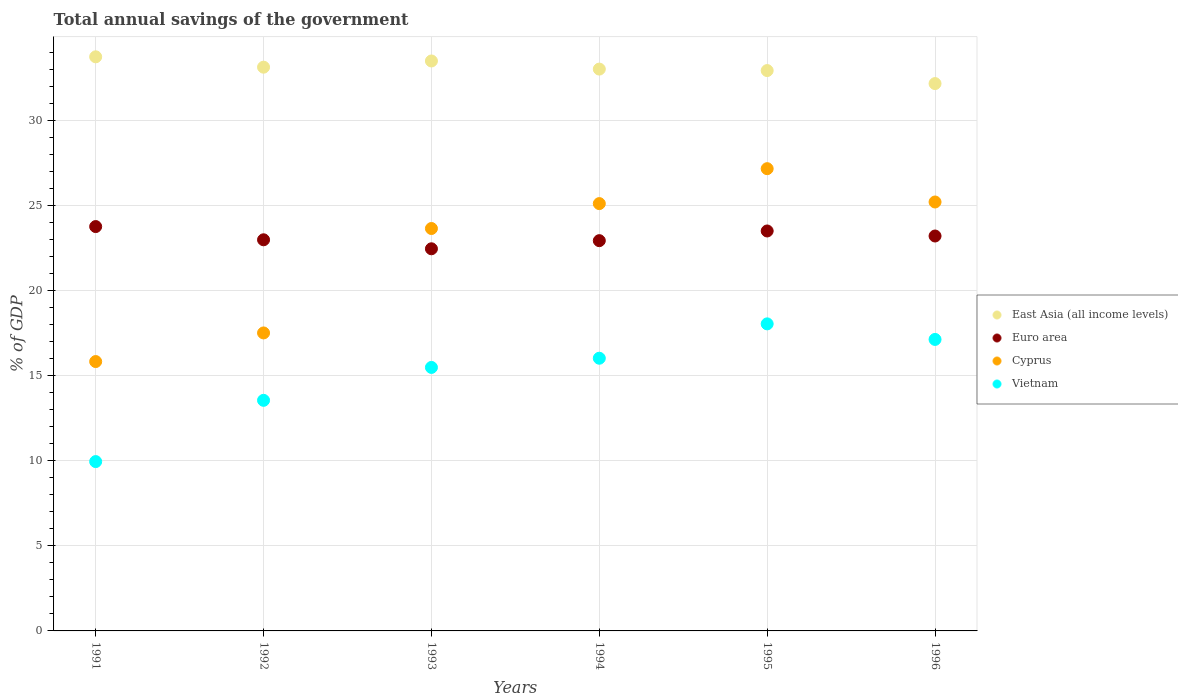Is the number of dotlines equal to the number of legend labels?
Your answer should be compact. Yes. What is the total annual savings of the government in Cyprus in 1995?
Ensure brevity in your answer.  27.17. Across all years, what is the maximum total annual savings of the government in Vietnam?
Keep it short and to the point. 18.05. Across all years, what is the minimum total annual savings of the government in Vietnam?
Keep it short and to the point. 9.95. In which year was the total annual savings of the government in East Asia (all income levels) minimum?
Your response must be concise. 1996. What is the total total annual savings of the government in Euro area in the graph?
Keep it short and to the point. 138.88. What is the difference between the total annual savings of the government in East Asia (all income levels) in 1991 and that in 1994?
Your response must be concise. 0.72. What is the difference between the total annual savings of the government in East Asia (all income levels) in 1994 and the total annual savings of the government in Cyprus in 1996?
Make the answer very short. 7.81. What is the average total annual savings of the government in Vietnam per year?
Ensure brevity in your answer.  15.03. In the year 1994, what is the difference between the total annual savings of the government in Euro area and total annual savings of the government in Cyprus?
Ensure brevity in your answer.  -2.18. What is the ratio of the total annual savings of the government in East Asia (all income levels) in 1992 to that in 1993?
Provide a short and direct response. 0.99. Is the total annual savings of the government in East Asia (all income levels) in 1991 less than that in 1993?
Ensure brevity in your answer.  No. What is the difference between the highest and the second highest total annual savings of the government in Cyprus?
Keep it short and to the point. 1.96. What is the difference between the highest and the lowest total annual savings of the government in Vietnam?
Keep it short and to the point. 8.1. In how many years, is the total annual savings of the government in Euro area greater than the average total annual savings of the government in Euro area taken over all years?
Offer a very short reply. 3. Is it the case that in every year, the sum of the total annual savings of the government in Euro area and total annual savings of the government in East Asia (all income levels)  is greater than the sum of total annual savings of the government in Vietnam and total annual savings of the government in Cyprus?
Offer a very short reply. Yes. Does the total annual savings of the government in Euro area monotonically increase over the years?
Your answer should be very brief. No. Is the total annual savings of the government in Cyprus strictly less than the total annual savings of the government in Euro area over the years?
Offer a very short reply. No. How many dotlines are there?
Your answer should be compact. 4. How many years are there in the graph?
Provide a succinct answer. 6. What is the difference between two consecutive major ticks on the Y-axis?
Keep it short and to the point. 5. Does the graph contain any zero values?
Your response must be concise. No. How are the legend labels stacked?
Your answer should be very brief. Vertical. What is the title of the graph?
Provide a short and direct response. Total annual savings of the government. Does "OECD members" appear as one of the legend labels in the graph?
Keep it short and to the point. No. What is the label or title of the X-axis?
Provide a succinct answer. Years. What is the label or title of the Y-axis?
Your response must be concise. % of GDP. What is the % of GDP in East Asia (all income levels) in 1991?
Keep it short and to the point. 33.75. What is the % of GDP in Euro area in 1991?
Your answer should be compact. 23.77. What is the % of GDP of Cyprus in 1991?
Keep it short and to the point. 15.83. What is the % of GDP in Vietnam in 1991?
Offer a very short reply. 9.95. What is the % of GDP of East Asia (all income levels) in 1992?
Give a very brief answer. 33.14. What is the % of GDP of Euro area in 1992?
Provide a short and direct response. 22.99. What is the % of GDP in Cyprus in 1992?
Your answer should be very brief. 17.52. What is the % of GDP in Vietnam in 1992?
Provide a short and direct response. 13.55. What is the % of GDP in East Asia (all income levels) in 1993?
Offer a very short reply. 33.5. What is the % of GDP in Euro area in 1993?
Your response must be concise. 22.46. What is the % of GDP in Cyprus in 1993?
Offer a terse response. 23.65. What is the % of GDP in Vietnam in 1993?
Provide a succinct answer. 15.49. What is the % of GDP of East Asia (all income levels) in 1994?
Your answer should be very brief. 33.02. What is the % of GDP of Euro area in 1994?
Offer a very short reply. 22.94. What is the % of GDP in Cyprus in 1994?
Your response must be concise. 25.12. What is the % of GDP of Vietnam in 1994?
Provide a short and direct response. 16.03. What is the % of GDP in East Asia (all income levels) in 1995?
Keep it short and to the point. 32.94. What is the % of GDP in Euro area in 1995?
Keep it short and to the point. 23.51. What is the % of GDP in Cyprus in 1995?
Provide a succinct answer. 27.17. What is the % of GDP of Vietnam in 1995?
Your answer should be very brief. 18.05. What is the % of GDP of East Asia (all income levels) in 1996?
Provide a succinct answer. 32.17. What is the % of GDP in Euro area in 1996?
Your answer should be very brief. 23.21. What is the % of GDP in Cyprus in 1996?
Make the answer very short. 25.21. What is the % of GDP in Vietnam in 1996?
Offer a very short reply. 17.13. Across all years, what is the maximum % of GDP of East Asia (all income levels)?
Provide a succinct answer. 33.75. Across all years, what is the maximum % of GDP in Euro area?
Make the answer very short. 23.77. Across all years, what is the maximum % of GDP of Cyprus?
Provide a short and direct response. 27.17. Across all years, what is the maximum % of GDP of Vietnam?
Offer a terse response. 18.05. Across all years, what is the minimum % of GDP of East Asia (all income levels)?
Your answer should be compact. 32.17. Across all years, what is the minimum % of GDP of Euro area?
Keep it short and to the point. 22.46. Across all years, what is the minimum % of GDP in Cyprus?
Offer a very short reply. 15.83. Across all years, what is the minimum % of GDP in Vietnam?
Give a very brief answer. 9.95. What is the total % of GDP in East Asia (all income levels) in the graph?
Ensure brevity in your answer.  198.52. What is the total % of GDP in Euro area in the graph?
Keep it short and to the point. 138.88. What is the total % of GDP of Cyprus in the graph?
Your answer should be very brief. 134.51. What is the total % of GDP in Vietnam in the graph?
Provide a short and direct response. 90.21. What is the difference between the % of GDP of East Asia (all income levels) in 1991 and that in 1992?
Your answer should be compact. 0.61. What is the difference between the % of GDP in Euro area in 1991 and that in 1992?
Make the answer very short. 0.78. What is the difference between the % of GDP in Cyprus in 1991 and that in 1992?
Ensure brevity in your answer.  -1.68. What is the difference between the % of GDP in Vietnam in 1991 and that in 1992?
Provide a short and direct response. -3.6. What is the difference between the % of GDP of East Asia (all income levels) in 1991 and that in 1993?
Offer a terse response. 0.24. What is the difference between the % of GDP of Euro area in 1991 and that in 1993?
Your response must be concise. 1.31. What is the difference between the % of GDP of Cyprus in 1991 and that in 1993?
Offer a very short reply. -7.82. What is the difference between the % of GDP of Vietnam in 1991 and that in 1993?
Your response must be concise. -5.54. What is the difference between the % of GDP in East Asia (all income levels) in 1991 and that in 1994?
Keep it short and to the point. 0.72. What is the difference between the % of GDP of Euro area in 1991 and that in 1994?
Offer a very short reply. 0.83. What is the difference between the % of GDP of Cyprus in 1991 and that in 1994?
Provide a short and direct response. -9.28. What is the difference between the % of GDP in Vietnam in 1991 and that in 1994?
Your response must be concise. -6.08. What is the difference between the % of GDP in East Asia (all income levels) in 1991 and that in 1995?
Make the answer very short. 0.81. What is the difference between the % of GDP of Euro area in 1991 and that in 1995?
Ensure brevity in your answer.  0.26. What is the difference between the % of GDP of Cyprus in 1991 and that in 1995?
Provide a succinct answer. -11.34. What is the difference between the % of GDP of Vietnam in 1991 and that in 1995?
Give a very brief answer. -8.1. What is the difference between the % of GDP of East Asia (all income levels) in 1991 and that in 1996?
Offer a terse response. 1.57. What is the difference between the % of GDP in Euro area in 1991 and that in 1996?
Provide a succinct answer. 0.55. What is the difference between the % of GDP in Cyprus in 1991 and that in 1996?
Ensure brevity in your answer.  -9.38. What is the difference between the % of GDP in Vietnam in 1991 and that in 1996?
Provide a short and direct response. -7.18. What is the difference between the % of GDP of East Asia (all income levels) in 1992 and that in 1993?
Your response must be concise. -0.36. What is the difference between the % of GDP of Euro area in 1992 and that in 1993?
Your answer should be compact. 0.53. What is the difference between the % of GDP in Cyprus in 1992 and that in 1993?
Your response must be concise. -6.14. What is the difference between the % of GDP in Vietnam in 1992 and that in 1993?
Offer a terse response. -1.93. What is the difference between the % of GDP in East Asia (all income levels) in 1992 and that in 1994?
Your answer should be compact. 0.11. What is the difference between the % of GDP in Euro area in 1992 and that in 1994?
Your answer should be very brief. 0.05. What is the difference between the % of GDP of Cyprus in 1992 and that in 1994?
Keep it short and to the point. -7.6. What is the difference between the % of GDP in Vietnam in 1992 and that in 1994?
Provide a succinct answer. -2.47. What is the difference between the % of GDP of East Asia (all income levels) in 1992 and that in 1995?
Your answer should be compact. 0.2. What is the difference between the % of GDP in Euro area in 1992 and that in 1995?
Give a very brief answer. -0.52. What is the difference between the % of GDP in Cyprus in 1992 and that in 1995?
Provide a succinct answer. -9.66. What is the difference between the % of GDP in Vietnam in 1992 and that in 1995?
Ensure brevity in your answer.  -4.49. What is the difference between the % of GDP of East Asia (all income levels) in 1992 and that in 1996?
Your answer should be very brief. 0.96. What is the difference between the % of GDP in Euro area in 1992 and that in 1996?
Offer a very short reply. -0.22. What is the difference between the % of GDP in Cyprus in 1992 and that in 1996?
Give a very brief answer. -7.7. What is the difference between the % of GDP in Vietnam in 1992 and that in 1996?
Ensure brevity in your answer.  -3.58. What is the difference between the % of GDP in East Asia (all income levels) in 1993 and that in 1994?
Your answer should be compact. 0.48. What is the difference between the % of GDP in Euro area in 1993 and that in 1994?
Offer a terse response. -0.48. What is the difference between the % of GDP in Cyprus in 1993 and that in 1994?
Your answer should be very brief. -1.46. What is the difference between the % of GDP in Vietnam in 1993 and that in 1994?
Give a very brief answer. -0.54. What is the difference between the % of GDP in East Asia (all income levels) in 1993 and that in 1995?
Ensure brevity in your answer.  0.56. What is the difference between the % of GDP of Euro area in 1993 and that in 1995?
Your answer should be very brief. -1.05. What is the difference between the % of GDP in Cyprus in 1993 and that in 1995?
Ensure brevity in your answer.  -3.52. What is the difference between the % of GDP in Vietnam in 1993 and that in 1995?
Provide a short and direct response. -2.56. What is the difference between the % of GDP in East Asia (all income levels) in 1993 and that in 1996?
Provide a short and direct response. 1.33. What is the difference between the % of GDP of Euro area in 1993 and that in 1996?
Provide a succinct answer. -0.75. What is the difference between the % of GDP in Cyprus in 1993 and that in 1996?
Give a very brief answer. -1.56. What is the difference between the % of GDP in Vietnam in 1993 and that in 1996?
Keep it short and to the point. -1.65. What is the difference between the % of GDP in East Asia (all income levels) in 1994 and that in 1995?
Offer a very short reply. 0.09. What is the difference between the % of GDP in Euro area in 1994 and that in 1995?
Keep it short and to the point. -0.57. What is the difference between the % of GDP of Cyprus in 1994 and that in 1995?
Give a very brief answer. -2.05. What is the difference between the % of GDP of Vietnam in 1994 and that in 1995?
Give a very brief answer. -2.02. What is the difference between the % of GDP of East Asia (all income levels) in 1994 and that in 1996?
Ensure brevity in your answer.  0.85. What is the difference between the % of GDP in Euro area in 1994 and that in 1996?
Offer a terse response. -0.27. What is the difference between the % of GDP of Cyprus in 1994 and that in 1996?
Your answer should be very brief. -0.09. What is the difference between the % of GDP in Vietnam in 1994 and that in 1996?
Ensure brevity in your answer.  -1.11. What is the difference between the % of GDP in East Asia (all income levels) in 1995 and that in 1996?
Give a very brief answer. 0.76. What is the difference between the % of GDP in Euro area in 1995 and that in 1996?
Keep it short and to the point. 0.3. What is the difference between the % of GDP of Cyprus in 1995 and that in 1996?
Your answer should be compact. 1.96. What is the difference between the % of GDP in Vietnam in 1995 and that in 1996?
Give a very brief answer. 0.91. What is the difference between the % of GDP in East Asia (all income levels) in 1991 and the % of GDP in Euro area in 1992?
Make the answer very short. 10.76. What is the difference between the % of GDP of East Asia (all income levels) in 1991 and the % of GDP of Cyprus in 1992?
Offer a terse response. 16.23. What is the difference between the % of GDP in East Asia (all income levels) in 1991 and the % of GDP in Vietnam in 1992?
Ensure brevity in your answer.  20.19. What is the difference between the % of GDP in Euro area in 1991 and the % of GDP in Cyprus in 1992?
Offer a very short reply. 6.25. What is the difference between the % of GDP of Euro area in 1991 and the % of GDP of Vietnam in 1992?
Ensure brevity in your answer.  10.21. What is the difference between the % of GDP in Cyprus in 1991 and the % of GDP in Vietnam in 1992?
Give a very brief answer. 2.28. What is the difference between the % of GDP of East Asia (all income levels) in 1991 and the % of GDP of Euro area in 1993?
Your response must be concise. 11.28. What is the difference between the % of GDP of East Asia (all income levels) in 1991 and the % of GDP of Cyprus in 1993?
Ensure brevity in your answer.  10.09. What is the difference between the % of GDP of East Asia (all income levels) in 1991 and the % of GDP of Vietnam in 1993?
Your answer should be very brief. 18.26. What is the difference between the % of GDP of Euro area in 1991 and the % of GDP of Cyprus in 1993?
Your response must be concise. 0.11. What is the difference between the % of GDP of Euro area in 1991 and the % of GDP of Vietnam in 1993?
Your response must be concise. 8.28. What is the difference between the % of GDP of Cyprus in 1991 and the % of GDP of Vietnam in 1993?
Provide a succinct answer. 0.34. What is the difference between the % of GDP in East Asia (all income levels) in 1991 and the % of GDP in Euro area in 1994?
Make the answer very short. 10.81. What is the difference between the % of GDP of East Asia (all income levels) in 1991 and the % of GDP of Cyprus in 1994?
Provide a short and direct response. 8.63. What is the difference between the % of GDP of East Asia (all income levels) in 1991 and the % of GDP of Vietnam in 1994?
Keep it short and to the point. 17.72. What is the difference between the % of GDP of Euro area in 1991 and the % of GDP of Cyprus in 1994?
Keep it short and to the point. -1.35. What is the difference between the % of GDP in Euro area in 1991 and the % of GDP in Vietnam in 1994?
Ensure brevity in your answer.  7.74. What is the difference between the % of GDP of Cyprus in 1991 and the % of GDP of Vietnam in 1994?
Offer a terse response. -0.2. What is the difference between the % of GDP of East Asia (all income levels) in 1991 and the % of GDP of Euro area in 1995?
Keep it short and to the point. 10.24. What is the difference between the % of GDP in East Asia (all income levels) in 1991 and the % of GDP in Cyprus in 1995?
Provide a succinct answer. 6.58. What is the difference between the % of GDP in East Asia (all income levels) in 1991 and the % of GDP in Vietnam in 1995?
Provide a succinct answer. 15.7. What is the difference between the % of GDP of Euro area in 1991 and the % of GDP of Cyprus in 1995?
Your response must be concise. -3.4. What is the difference between the % of GDP of Euro area in 1991 and the % of GDP of Vietnam in 1995?
Keep it short and to the point. 5.72. What is the difference between the % of GDP of Cyprus in 1991 and the % of GDP of Vietnam in 1995?
Your answer should be compact. -2.22. What is the difference between the % of GDP of East Asia (all income levels) in 1991 and the % of GDP of Euro area in 1996?
Offer a very short reply. 10.53. What is the difference between the % of GDP in East Asia (all income levels) in 1991 and the % of GDP in Cyprus in 1996?
Offer a terse response. 8.53. What is the difference between the % of GDP in East Asia (all income levels) in 1991 and the % of GDP in Vietnam in 1996?
Make the answer very short. 16.61. What is the difference between the % of GDP of Euro area in 1991 and the % of GDP of Cyprus in 1996?
Provide a succinct answer. -1.45. What is the difference between the % of GDP in Euro area in 1991 and the % of GDP in Vietnam in 1996?
Provide a short and direct response. 6.63. What is the difference between the % of GDP in Cyprus in 1991 and the % of GDP in Vietnam in 1996?
Offer a very short reply. -1.3. What is the difference between the % of GDP in East Asia (all income levels) in 1992 and the % of GDP in Euro area in 1993?
Your response must be concise. 10.68. What is the difference between the % of GDP in East Asia (all income levels) in 1992 and the % of GDP in Cyprus in 1993?
Your answer should be compact. 9.48. What is the difference between the % of GDP of East Asia (all income levels) in 1992 and the % of GDP of Vietnam in 1993?
Give a very brief answer. 17.65. What is the difference between the % of GDP of Euro area in 1992 and the % of GDP of Cyprus in 1993?
Provide a succinct answer. -0.66. What is the difference between the % of GDP of Euro area in 1992 and the % of GDP of Vietnam in 1993?
Offer a terse response. 7.5. What is the difference between the % of GDP in Cyprus in 1992 and the % of GDP in Vietnam in 1993?
Offer a very short reply. 2.03. What is the difference between the % of GDP in East Asia (all income levels) in 1992 and the % of GDP in Euro area in 1994?
Provide a short and direct response. 10.2. What is the difference between the % of GDP of East Asia (all income levels) in 1992 and the % of GDP of Cyprus in 1994?
Provide a short and direct response. 8.02. What is the difference between the % of GDP in East Asia (all income levels) in 1992 and the % of GDP in Vietnam in 1994?
Offer a very short reply. 17.11. What is the difference between the % of GDP in Euro area in 1992 and the % of GDP in Cyprus in 1994?
Your answer should be compact. -2.13. What is the difference between the % of GDP in Euro area in 1992 and the % of GDP in Vietnam in 1994?
Offer a terse response. 6.96. What is the difference between the % of GDP in Cyprus in 1992 and the % of GDP in Vietnam in 1994?
Your answer should be very brief. 1.49. What is the difference between the % of GDP in East Asia (all income levels) in 1992 and the % of GDP in Euro area in 1995?
Give a very brief answer. 9.63. What is the difference between the % of GDP of East Asia (all income levels) in 1992 and the % of GDP of Cyprus in 1995?
Your answer should be compact. 5.97. What is the difference between the % of GDP in East Asia (all income levels) in 1992 and the % of GDP in Vietnam in 1995?
Your response must be concise. 15.09. What is the difference between the % of GDP of Euro area in 1992 and the % of GDP of Cyprus in 1995?
Give a very brief answer. -4.18. What is the difference between the % of GDP in Euro area in 1992 and the % of GDP in Vietnam in 1995?
Provide a short and direct response. 4.94. What is the difference between the % of GDP in Cyprus in 1992 and the % of GDP in Vietnam in 1995?
Provide a succinct answer. -0.53. What is the difference between the % of GDP of East Asia (all income levels) in 1992 and the % of GDP of Euro area in 1996?
Your answer should be very brief. 9.92. What is the difference between the % of GDP of East Asia (all income levels) in 1992 and the % of GDP of Cyprus in 1996?
Ensure brevity in your answer.  7.92. What is the difference between the % of GDP in East Asia (all income levels) in 1992 and the % of GDP in Vietnam in 1996?
Provide a succinct answer. 16. What is the difference between the % of GDP of Euro area in 1992 and the % of GDP of Cyprus in 1996?
Ensure brevity in your answer.  -2.22. What is the difference between the % of GDP in Euro area in 1992 and the % of GDP in Vietnam in 1996?
Keep it short and to the point. 5.86. What is the difference between the % of GDP in Cyprus in 1992 and the % of GDP in Vietnam in 1996?
Offer a terse response. 0.38. What is the difference between the % of GDP in East Asia (all income levels) in 1993 and the % of GDP in Euro area in 1994?
Keep it short and to the point. 10.56. What is the difference between the % of GDP in East Asia (all income levels) in 1993 and the % of GDP in Cyprus in 1994?
Offer a terse response. 8.38. What is the difference between the % of GDP of East Asia (all income levels) in 1993 and the % of GDP of Vietnam in 1994?
Provide a succinct answer. 17.47. What is the difference between the % of GDP in Euro area in 1993 and the % of GDP in Cyprus in 1994?
Ensure brevity in your answer.  -2.66. What is the difference between the % of GDP of Euro area in 1993 and the % of GDP of Vietnam in 1994?
Your response must be concise. 6.43. What is the difference between the % of GDP of Cyprus in 1993 and the % of GDP of Vietnam in 1994?
Keep it short and to the point. 7.63. What is the difference between the % of GDP of East Asia (all income levels) in 1993 and the % of GDP of Euro area in 1995?
Make the answer very short. 9.99. What is the difference between the % of GDP in East Asia (all income levels) in 1993 and the % of GDP in Cyprus in 1995?
Make the answer very short. 6.33. What is the difference between the % of GDP in East Asia (all income levels) in 1993 and the % of GDP in Vietnam in 1995?
Your response must be concise. 15.45. What is the difference between the % of GDP of Euro area in 1993 and the % of GDP of Cyprus in 1995?
Provide a succinct answer. -4.71. What is the difference between the % of GDP in Euro area in 1993 and the % of GDP in Vietnam in 1995?
Offer a very short reply. 4.41. What is the difference between the % of GDP in Cyprus in 1993 and the % of GDP in Vietnam in 1995?
Provide a short and direct response. 5.61. What is the difference between the % of GDP in East Asia (all income levels) in 1993 and the % of GDP in Euro area in 1996?
Your response must be concise. 10.29. What is the difference between the % of GDP in East Asia (all income levels) in 1993 and the % of GDP in Cyprus in 1996?
Provide a short and direct response. 8.29. What is the difference between the % of GDP of East Asia (all income levels) in 1993 and the % of GDP of Vietnam in 1996?
Keep it short and to the point. 16.37. What is the difference between the % of GDP in Euro area in 1993 and the % of GDP in Cyprus in 1996?
Offer a very short reply. -2.75. What is the difference between the % of GDP in Euro area in 1993 and the % of GDP in Vietnam in 1996?
Offer a very short reply. 5.33. What is the difference between the % of GDP in Cyprus in 1993 and the % of GDP in Vietnam in 1996?
Your response must be concise. 6.52. What is the difference between the % of GDP in East Asia (all income levels) in 1994 and the % of GDP in Euro area in 1995?
Your response must be concise. 9.52. What is the difference between the % of GDP in East Asia (all income levels) in 1994 and the % of GDP in Cyprus in 1995?
Offer a very short reply. 5.85. What is the difference between the % of GDP of East Asia (all income levels) in 1994 and the % of GDP of Vietnam in 1995?
Offer a terse response. 14.98. What is the difference between the % of GDP in Euro area in 1994 and the % of GDP in Cyprus in 1995?
Ensure brevity in your answer.  -4.23. What is the difference between the % of GDP in Euro area in 1994 and the % of GDP in Vietnam in 1995?
Provide a short and direct response. 4.89. What is the difference between the % of GDP of Cyprus in 1994 and the % of GDP of Vietnam in 1995?
Provide a short and direct response. 7.07. What is the difference between the % of GDP in East Asia (all income levels) in 1994 and the % of GDP in Euro area in 1996?
Make the answer very short. 9.81. What is the difference between the % of GDP in East Asia (all income levels) in 1994 and the % of GDP in Cyprus in 1996?
Make the answer very short. 7.81. What is the difference between the % of GDP of East Asia (all income levels) in 1994 and the % of GDP of Vietnam in 1996?
Offer a very short reply. 15.89. What is the difference between the % of GDP of Euro area in 1994 and the % of GDP of Cyprus in 1996?
Keep it short and to the point. -2.27. What is the difference between the % of GDP of Euro area in 1994 and the % of GDP of Vietnam in 1996?
Keep it short and to the point. 5.81. What is the difference between the % of GDP of Cyprus in 1994 and the % of GDP of Vietnam in 1996?
Give a very brief answer. 7.98. What is the difference between the % of GDP in East Asia (all income levels) in 1995 and the % of GDP in Euro area in 1996?
Your answer should be very brief. 9.72. What is the difference between the % of GDP in East Asia (all income levels) in 1995 and the % of GDP in Cyprus in 1996?
Offer a terse response. 7.73. What is the difference between the % of GDP in East Asia (all income levels) in 1995 and the % of GDP in Vietnam in 1996?
Make the answer very short. 15.8. What is the difference between the % of GDP in Euro area in 1995 and the % of GDP in Cyprus in 1996?
Provide a succinct answer. -1.7. What is the difference between the % of GDP in Euro area in 1995 and the % of GDP in Vietnam in 1996?
Make the answer very short. 6.38. What is the difference between the % of GDP of Cyprus in 1995 and the % of GDP of Vietnam in 1996?
Your response must be concise. 10.04. What is the average % of GDP of East Asia (all income levels) per year?
Your response must be concise. 33.09. What is the average % of GDP in Euro area per year?
Provide a succinct answer. 23.15. What is the average % of GDP in Cyprus per year?
Provide a succinct answer. 22.42. What is the average % of GDP in Vietnam per year?
Give a very brief answer. 15.03. In the year 1991, what is the difference between the % of GDP of East Asia (all income levels) and % of GDP of Euro area?
Your answer should be compact. 9.98. In the year 1991, what is the difference between the % of GDP of East Asia (all income levels) and % of GDP of Cyprus?
Keep it short and to the point. 17.91. In the year 1991, what is the difference between the % of GDP of East Asia (all income levels) and % of GDP of Vietnam?
Offer a terse response. 23.79. In the year 1991, what is the difference between the % of GDP of Euro area and % of GDP of Cyprus?
Ensure brevity in your answer.  7.93. In the year 1991, what is the difference between the % of GDP of Euro area and % of GDP of Vietnam?
Your answer should be very brief. 13.81. In the year 1991, what is the difference between the % of GDP of Cyprus and % of GDP of Vietnam?
Offer a terse response. 5.88. In the year 1992, what is the difference between the % of GDP of East Asia (all income levels) and % of GDP of Euro area?
Your response must be concise. 10.15. In the year 1992, what is the difference between the % of GDP of East Asia (all income levels) and % of GDP of Cyprus?
Provide a short and direct response. 15.62. In the year 1992, what is the difference between the % of GDP in East Asia (all income levels) and % of GDP in Vietnam?
Your answer should be compact. 19.58. In the year 1992, what is the difference between the % of GDP in Euro area and % of GDP in Cyprus?
Provide a short and direct response. 5.48. In the year 1992, what is the difference between the % of GDP in Euro area and % of GDP in Vietnam?
Make the answer very short. 9.44. In the year 1992, what is the difference between the % of GDP of Cyprus and % of GDP of Vietnam?
Keep it short and to the point. 3.96. In the year 1993, what is the difference between the % of GDP in East Asia (all income levels) and % of GDP in Euro area?
Offer a very short reply. 11.04. In the year 1993, what is the difference between the % of GDP of East Asia (all income levels) and % of GDP of Cyprus?
Your answer should be compact. 9.85. In the year 1993, what is the difference between the % of GDP in East Asia (all income levels) and % of GDP in Vietnam?
Your answer should be very brief. 18.01. In the year 1993, what is the difference between the % of GDP in Euro area and % of GDP in Cyprus?
Your response must be concise. -1.19. In the year 1993, what is the difference between the % of GDP of Euro area and % of GDP of Vietnam?
Give a very brief answer. 6.97. In the year 1993, what is the difference between the % of GDP in Cyprus and % of GDP in Vietnam?
Your answer should be very brief. 8.17. In the year 1994, what is the difference between the % of GDP in East Asia (all income levels) and % of GDP in Euro area?
Your answer should be very brief. 10.09. In the year 1994, what is the difference between the % of GDP in East Asia (all income levels) and % of GDP in Cyprus?
Your answer should be very brief. 7.91. In the year 1994, what is the difference between the % of GDP of East Asia (all income levels) and % of GDP of Vietnam?
Your answer should be compact. 17. In the year 1994, what is the difference between the % of GDP of Euro area and % of GDP of Cyprus?
Ensure brevity in your answer.  -2.18. In the year 1994, what is the difference between the % of GDP of Euro area and % of GDP of Vietnam?
Offer a terse response. 6.91. In the year 1994, what is the difference between the % of GDP of Cyprus and % of GDP of Vietnam?
Keep it short and to the point. 9.09. In the year 1995, what is the difference between the % of GDP in East Asia (all income levels) and % of GDP in Euro area?
Provide a succinct answer. 9.43. In the year 1995, what is the difference between the % of GDP of East Asia (all income levels) and % of GDP of Cyprus?
Provide a succinct answer. 5.77. In the year 1995, what is the difference between the % of GDP in East Asia (all income levels) and % of GDP in Vietnam?
Offer a very short reply. 14.89. In the year 1995, what is the difference between the % of GDP of Euro area and % of GDP of Cyprus?
Provide a short and direct response. -3.66. In the year 1995, what is the difference between the % of GDP of Euro area and % of GDP of Vietnam?
Provide a succinct answer. 5.46. In the year 1995, what is the difference between the % of GDP of Cyprus and % of GDP of Vietnam?
Make the answer very short. 9.12. In the year 1996, what is the difference between the % of GDP of East Asia (all income levels) and % of GDP of Euro area?
Offer a terse response. 8.96. In the year 1996, what is the difference between the % of GDP in East Asia (all income levels) and % of GDP in Cyprus?
Give a very brief answer. 6.96. In the year 1996, what is the difference between the % of GDP of East Asia (all income levels) and % of GDP of Vietnam?
Provide a succinct answer. 15.04. In the year 1996, what is the difference between the % of GDP in Euro area and % of GDP in Cyprus?
Provide a succinct answer. -2. In the year 1996, what is the difference between the % of GDP of Euro area and % of GDP of Vietnam?
Your answer should be compact. 6.08. In the year 1996, what is the difference between the % of GDP in Cyprus and % of GDP in Vietnam?
Offer a very short reply. 8.08. What is the ratio of the % of GDP in East Asia (all income levels) in 1991 to that in 1992?
Provide a short and direct response. 1.02. What is the ratio of the % of GDP in Euro area in 1991 to that in 1992?
Provide a short and direct response. 1.03. What is the ratio of the % of GDP in Cyprus in 1991 to that in 1992?
Offer a terse response. 0.9. What is the ratio of the % of GDP in Vietnam in 1991 to that in 1992?
Make the answer very short. 0.73. What is the ratio of the % of GDP in East Asia (all income levels) in 1991 to that in 1993?
Provide a short and direct response. 1.01. What is the ratio of the % of GDP of Euro area in 1991 to that in 1993?
Keep it short and to the point. 1.06. What is the ratio of the % of GDP of Cyprus in 1991 to that in 1993?
Your response must be concise. 0.67. What is the ratio of the % of GDP in Vietnam in 1991 to that in 1993?
Your response must be concise. 0.64. What is the ratio of the % of GDP of East Asia (all income levels) in 1991 to that in 1994?
Provide a succinct answer. 1.02. What is the ratio of the % of GDP of Euro area in 1991 to that in 1994?
Your answer should be compact. 1.04. What is the ratio of the % of GDP in Cyprus in 1991 to that in 1994?
Keep it short and to the point. 0.63. What is the ratio of the % of GDP in Vietnam in 1991 to that in 1994?
Your response must be concise. 0.62. What is the ratio of the % of GDP in East Asia (all income levels) in 1991 to that in 1995?
Your answer should be compact. 1.02. What is the ratio of the % of GDP in Cyprus in 1991 to that in 1995?
Ensure brevity in your answer.  0.58. What is the ratio of the % of GDP in Vietnam in 1991 to that in 1995?
Offer a very short reply. 0.55. What is the ratio of the % of GDP of East Asia (all income levels) in 1991 to that in 1996?
Your response must be concise. 1.05. What is the ratio of the % of GDP in Euro area in 1991 to that in 1996?
Your answer should be compact. 1.02. What is the ratio of the % of GDP in Cyprus in 1991 to that in 1996?
Your response must be concise. 0.63. What is the ratio of the % of GDP in Vietnam in 1991 to that in 1996?
Your answer should be compact. 0.58. What is the ratio of the % of GDP in Euro area in 1992 to that in 1993?
Give a very brief answer. 1.02. What is the ratio of the % of GDP of Cyprus in 1992 to that in 1993?
Your answer should be compact. 0.74. What is the ratio of the % of GDP of Vietnam in 1992 to that in 1993?
Provide a short and direct response. 0.88. What is the ratio of the % of GDP in Cyprus in 1992 to that in 1994?
Give a very brief answer. 0.7. What is the ratio of the % of GDP in Vietnam in 1992 to that in 1994?
Make the answer very short. 0.85. What is the ratio of the % of GDP in East Asia (all income levels) in 1992 to that in 1995?
Your response must be concise. 1.01. What is the ratio of the % of GDP in Cyprus in 1992 to that in 1995?
Your answer should be compact. 0.64. What is the ratio of the % of GDP of Vietnam in 1992 to that in 1995?
Your response must be concise. 0.75. What is the ratio of the % of GDP in Euro area in 1992 to that in 1996?
Offer a very short reply. 0.99. What is the ratio of the % of GDP of Cyprus in 1992 to that in 1996?
Keep it short and to the point. 0.69. What is the ratio of the % of GDP in Vietnam in 1992 to that in 1996?
Provide a short and direct response. 0.79. What is the ratio of the % of GDP in East Asia (all income levels) in 1993 to that in 1994?
Your answer should be very brief. 1.01. What is the ratio of the % of GDP of Euro area in 1993 to that in 1994?
Ensure brevity in your answer.  0.98. What is the ratio of the % of GDP of Cyprus in 1993 to that in 1994?
Offer a very short reply. 0.94. What is the ratio of the % of GDP in Vietnam in 1993 to that in 1994?
Your answer should be very brief. 0.97. What is the ratio of the % of GDP in East Asia (all income levels) in 1993 to that in 1995?
Provide a short and direct response. 1.02. What is the ratio of the % of GDP of Euro area in 1993 to that in 1995?
Offer a terse response. 0.96. What is the ratio of the % of GDP of Cyprus in 1993 to that in 1995?
Provide a succinct answer. 0.87. What is the ratio of the % of GDP of Vietnam in 1993 to that in 1995?
Provide a short and direct response. 0.86. What is the ratio of the % of GDP in East Asia (all income levels) in 1993 to that in 1996?
Make the answer very short. 1.04. What is the ratio of the % of GDP in Euro area in 1993 to that in 1996?
Keep it short and to the point. 0.97. What is the ratio of the % of GDP in Cyprus in 1993 to that in 1996?
Provide a succinct answer. 0.94. What is the ratio of the % of GDP of Vietnam in 1993 to that in 1996?
Offer a terse response. 0.9. What is the ratio of the % of GDP of Euro area in 1994 to that in 1995?
Offer a terse response. 0.98. What is the ratio of the % of GDP of Cyprus in 1994 to that in 1995?
Make the answer very short. 0.92. What is the ratio of the % of GDP of Vietnam in 1994 to that in 1995?
Your answer should be very brief. 0.89. What is the ratio of the % of GDP in East Asia (all income levels) in 1994 to that in 1996?
Offer a very short reply. 1.03. What is the ratio of the % of GDP in Vietnam in 1994 to that in 1996?
Offer a terse response. 0.94. What is the ratio of the % of GDP in East Asia (all income levels) in 1995 to that in 1996?
Offer a terse response. 1.02. What is the ratio of the % of GDP in Euro area in 1995 to that in 1996?
Provide a succinct answer. 1.01. What is the ratio of the % of GDP in Cyprus in 1995 to that in 1996?
Make the answer very short. 1.08. What is the ratio of the % of GDP in Vietnam in 1995 to that in 1996?
Give a very brief answer. 1.05. What is the difference between the highest and the second highest % of GDP in East Asia (all income levels)?
Your response must be concise. 0.24. What is the difference between the highest and the second highest % of GDP in Euro area?
Your answer should be compact. 0.26. What is the difference between the highest and the second highest % of GDP in Cyprus?
Provide a succinct answer. 1.96. What is the difference between the highest and the second highest % of GDP in Vietnam?
Your answer should be very brief. 0.91. What is the difference between the highest and the lowest % of GDP in East Asia (all income levels)?
Keep it short and to the point. 1.57. What is the difference between the highest and the lowest % of GDP in Euro area?
Provide a short and direct response. 1.31. What is the difference between the highest and the lowest % of GDP in Cyprus?
Ensure brevity in your answer.  11.34. What is the difference between the highest and the lowest % of GDP in Vietnam?
Your answer should be very brief. 8.1. 